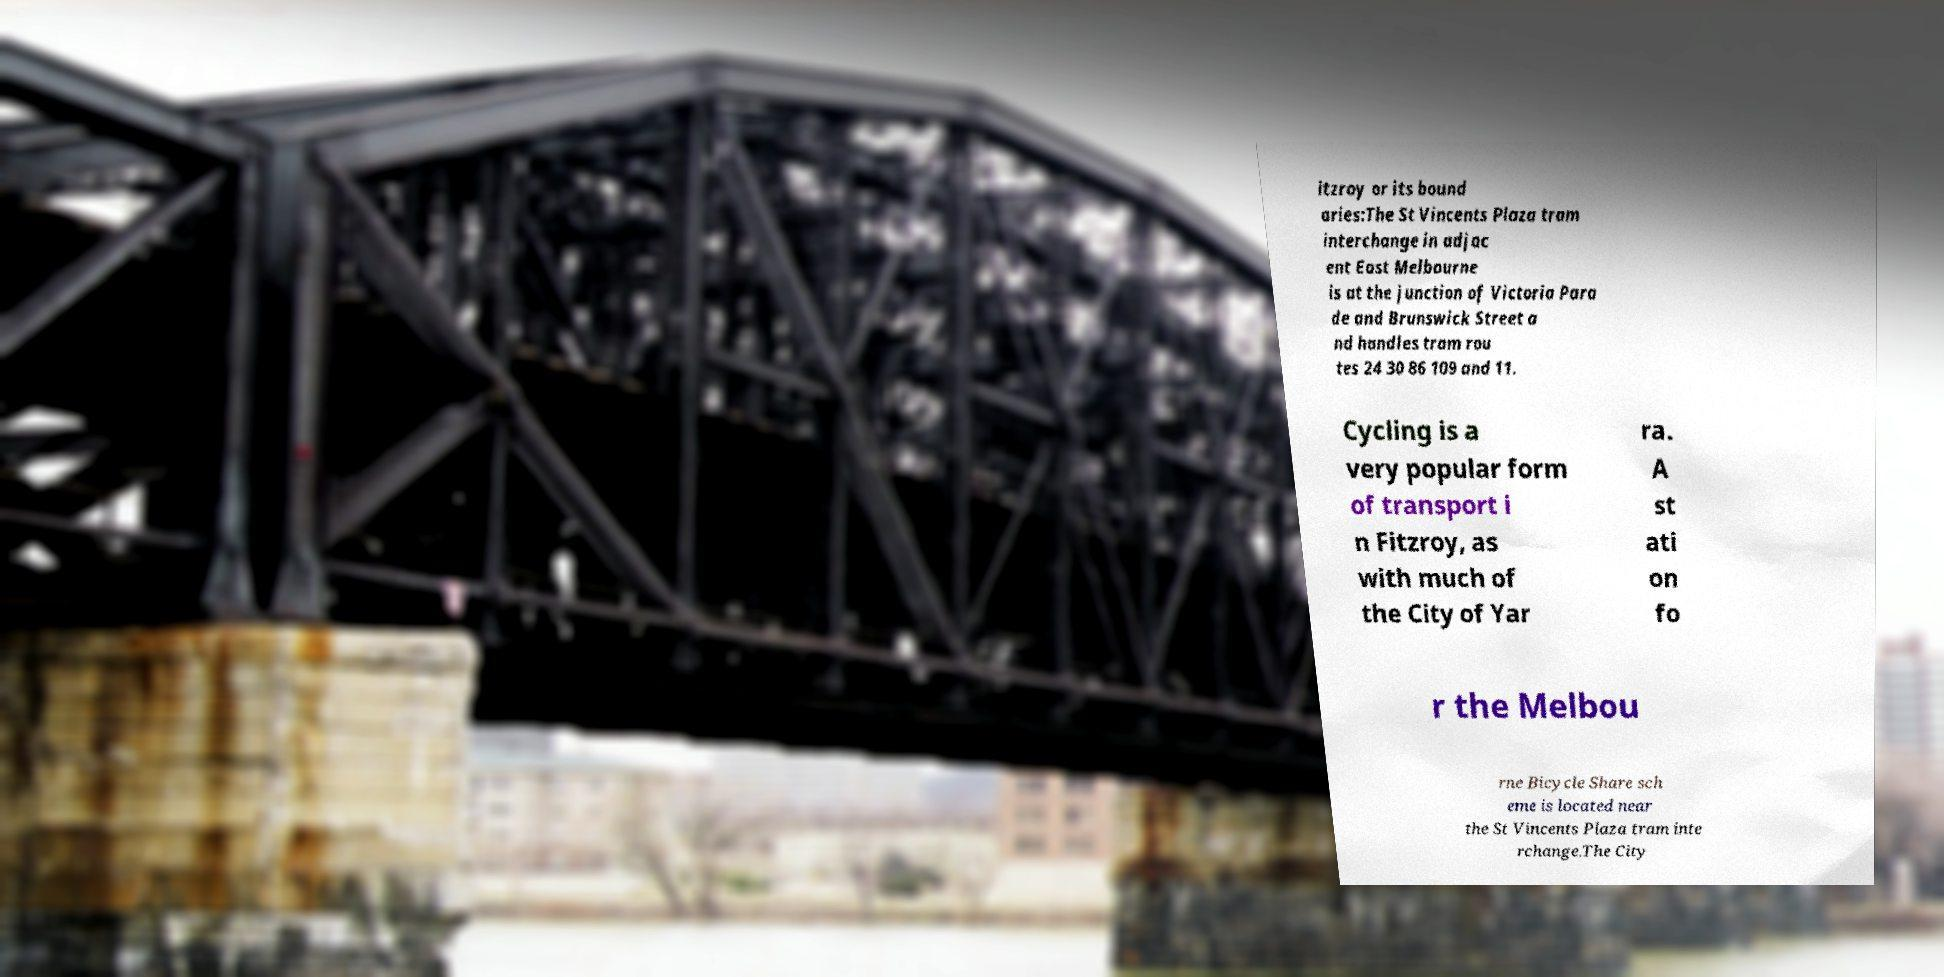I need the written content from this picture converted into text. Can you do that? itzroy or its bound aries:The St Vincents Plaza tram interchange in adjac ent East Melbourne is at the junction of Victoria Para de and Brunswick Street a nd handles tram rou tes 24 30 86 109 and 11. Cycling is a very popular form of transport i n Fitzroy, as with much of the City of Yar ra. A st ati on fo r the Melbou rne Bicycle Share sch eme is located near the St Vincents Plaza tram inte rchange.The City 